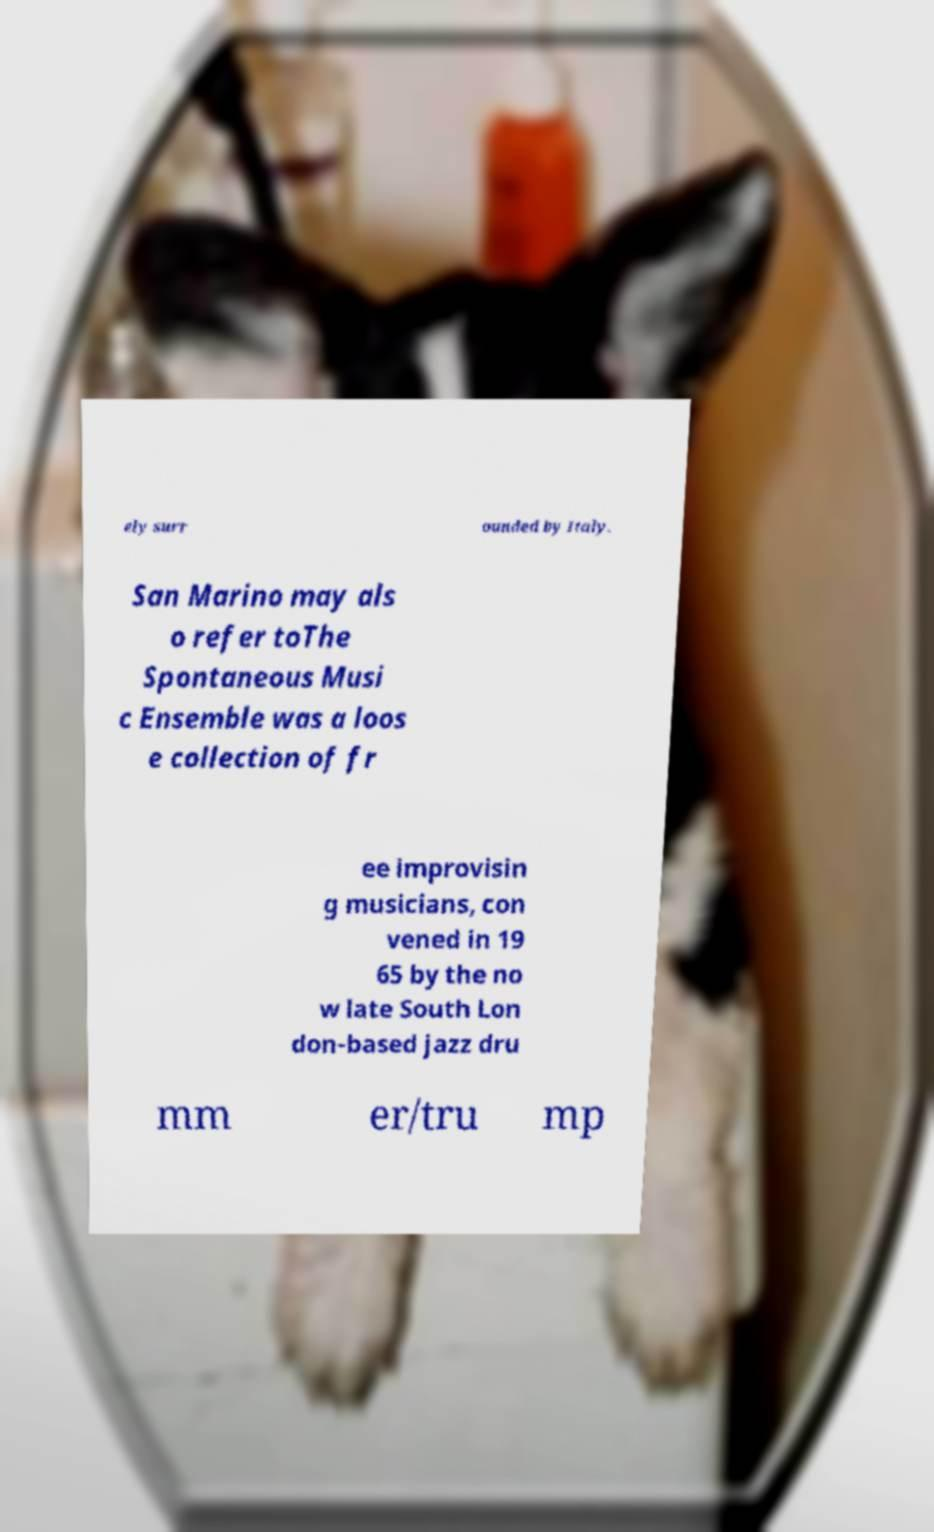Can you accurately transcribe the text from the provided image for me? ely surr ounded by Italy. San Marino may als o refer toThe Spontaneous Musi c Ensemble was a loos e collection of fr ee improvisin g musicians, con vened in 19 65 by the no w late South Lon don-based jazz dru mm er/tru mp 